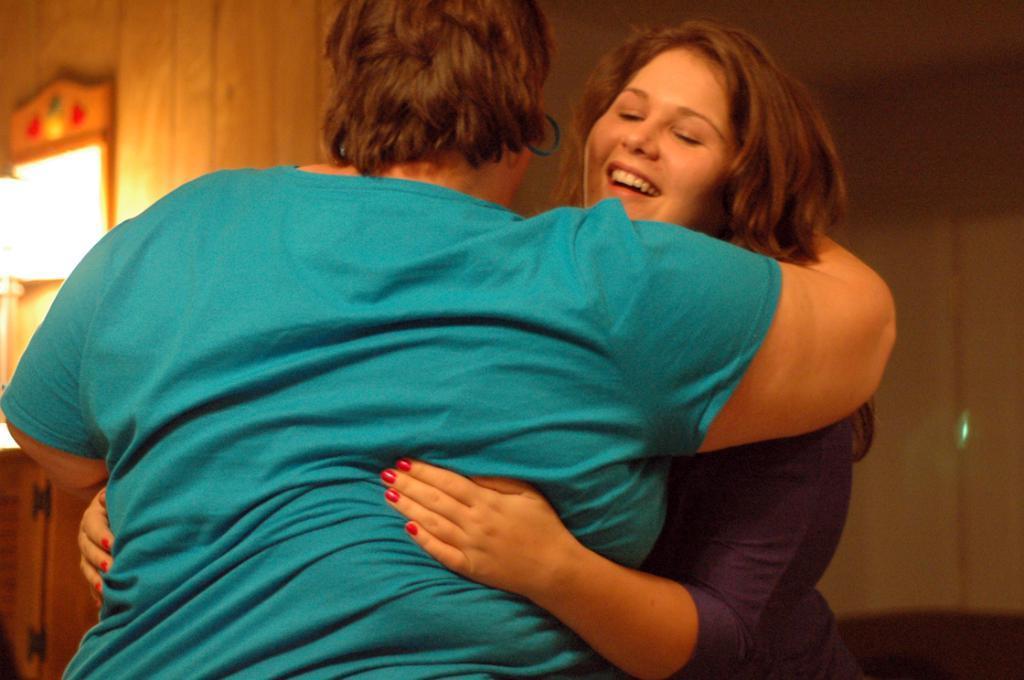Could you give a brief overview of what you see in this image? Here we can see two persons are hugging each other and she is smiling. In the background we can see wall. 